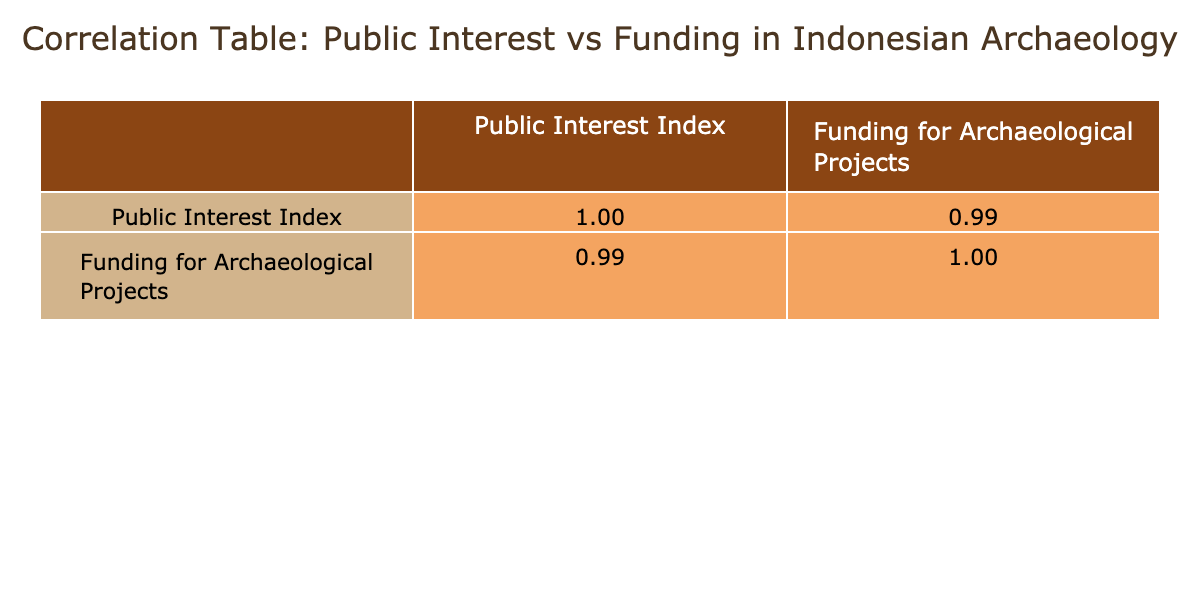What was the Public Interest Index in 2022? According to the table, the Public Interest Index for the year 2022 is listed as 85.
Answer: 85 What was the funding for archaeological projects in 2021? In the table, the funding for archaeological projects for 2021 is shown as 200,000 USD.
Answer: 200,000 USD Is there a positive correlation between Public Interest and Funding for Archaeological Projects? The correlation coefficient between Public Interest Index and Funding shows a positive relationship, indicating that as Public Interest increases, funding also tends to increase.
Answer: Yes What is the change in Public Interest Index from 2018 to 2023? The Public Interest Index increased from 65 in 2018 to 90 in 2023. The change can be calculated as 90 - 65 = 25.
Answer: 25 What is the average funding for archaeological projects from 2018 to 2023? To find the average funding, we add the funding amounts: 100,000 + 120,000 + 150,000 + 200,000 + 250,000 + 300,000 = 1,120,000 USD. Then, we divide this by the number of years, which is 6. Therefore, the average funding is 1,120,000 / 6 = 186,666.67 USD.
Answer: 186,666.67 USD In which year was the highest funding for archaeological projects recorded? The table indicates that the highest funding was recorded in 2023, with an amount of 300,000 USD.
Answer: 2023 If the Public Interest Index continues to increase by 5 points each year, what would the projected index be in 2025? Starting with the 2023 index of 90, if it increases by 5 points each year, by 2025 (which is 2 years later), the projected index would be 90 + (5 * 2) = 100.
Answer: 100 How much did the funding for archaeological projects increase from 2020 to 2022? The funding in 2020 was 150,000 USD, and in 2022 it was 250,000 USD. The increase can be calculated as 250,000 - 150,000 = 100,000 USD.
Answer: 100,000 USD What was the correlation coefficient between Public Interest Index and Funding for Archaeological Projects? The data in the correlation table shows that the correlation coefficient is 0.98, which indicates a very strong positive correlation between the two variables.
Answer: 0.98 